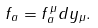<formula> <loc_0><loc_0><loc_500><loc_500>f _ { a } = f _ { a } ^ { \, \mu } d y _ { \mu } .</formula> 